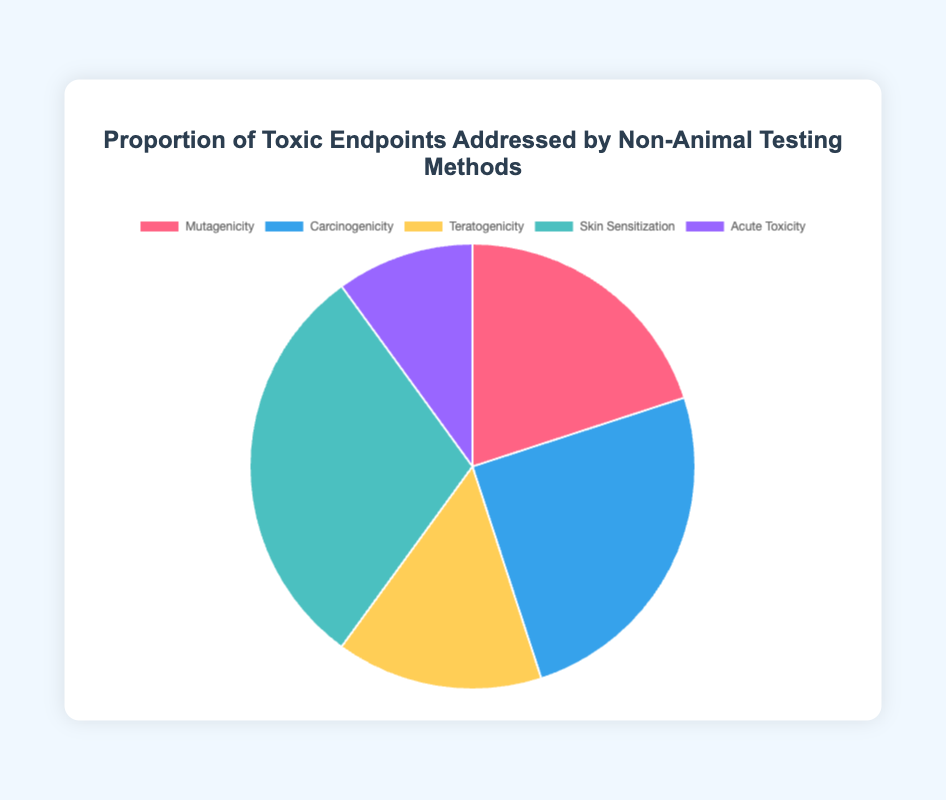What proportion of the pie chart is dedicated to Skin Sensitization? Locate the section of the pie chart labelled "Skin Sensitization" and note the displayed proportion.
Answer: 30% Which category represents the smallest proportion in the chart? Find the section with the smallest size (or the smallest percentage label) in the pie chart. That section represents the smallest proportion.
Answer: Acute Toxicity How much larger is the proportion of Carcinogenicity compared to Acute Toxicity? Locate the proportions for Carcinogenicity (25%) and Acute Toxicity (10%). Subtract the smaller proportion from the larger one: 25% - 10% = 15%.
Answer: 15% What is the combined proportion of Mutagenicity and Teratogenicity? Locate the proportions for Mutagenicity (20%) and Teratogenicity (15%). Add these values together: 20% + 15% = 35%.
Answer: 35% Which two toxic endpoints have a combined proportion that exceeds 50%? Identify the highest individual proportions and verify their combinations: Skin Sensitization (30%) and Carcinogenicity (25%). 30% + 25% = 55%, which is greater than 50%.
Answer: Skin Sensitization and Carcinogenicity What proportion is represented by Carcinogenicity, and what color is its corresponding pie slice? Find the section labeled "Carcinogenicity" which shows a proportion of 25%. The chart code specifies the color as blue.
Answer: 25% and blue Which endpoint has a greater proportion: Mutagenicity or Teratogenicity? Compare the displayed proportions for Mutagenicity (20%) and Teratogenicity (15%). Mutagenicity has a greater proportion.
Answer: Mutagenicity What is the difference in proportion between the largest and smallest sections of the pie chart? Identify the largest section (Skin Sensitization, 30%) and the smallest section (Acute Toxicity, 10%). Subtract the smaller proportion from the larger one: 30% - 10% = 20%.
Answer: 20% What is the average proportion of all the toxic endpoints in the pie chart? Add all proportions: 20% (Mutagenicity) + 25% (Carcinogenicity) + 15% (Teratogenicity) + 30% (Skin Sensitization) + 10% (Acute Toxicity) = 100%. Then divide by the number of endpoints: 100% / 5 = 20%.
Answer: 20% In visual terms, which section of the pie has the second-largest slice and what is its corresponding endpoint? Identify the sections visually to find the second-largest slice, after Skin Sensitization. The second-largest is labeled Carcinogenicity with a proportion of 25%.
Answer: Carcinogenicity 